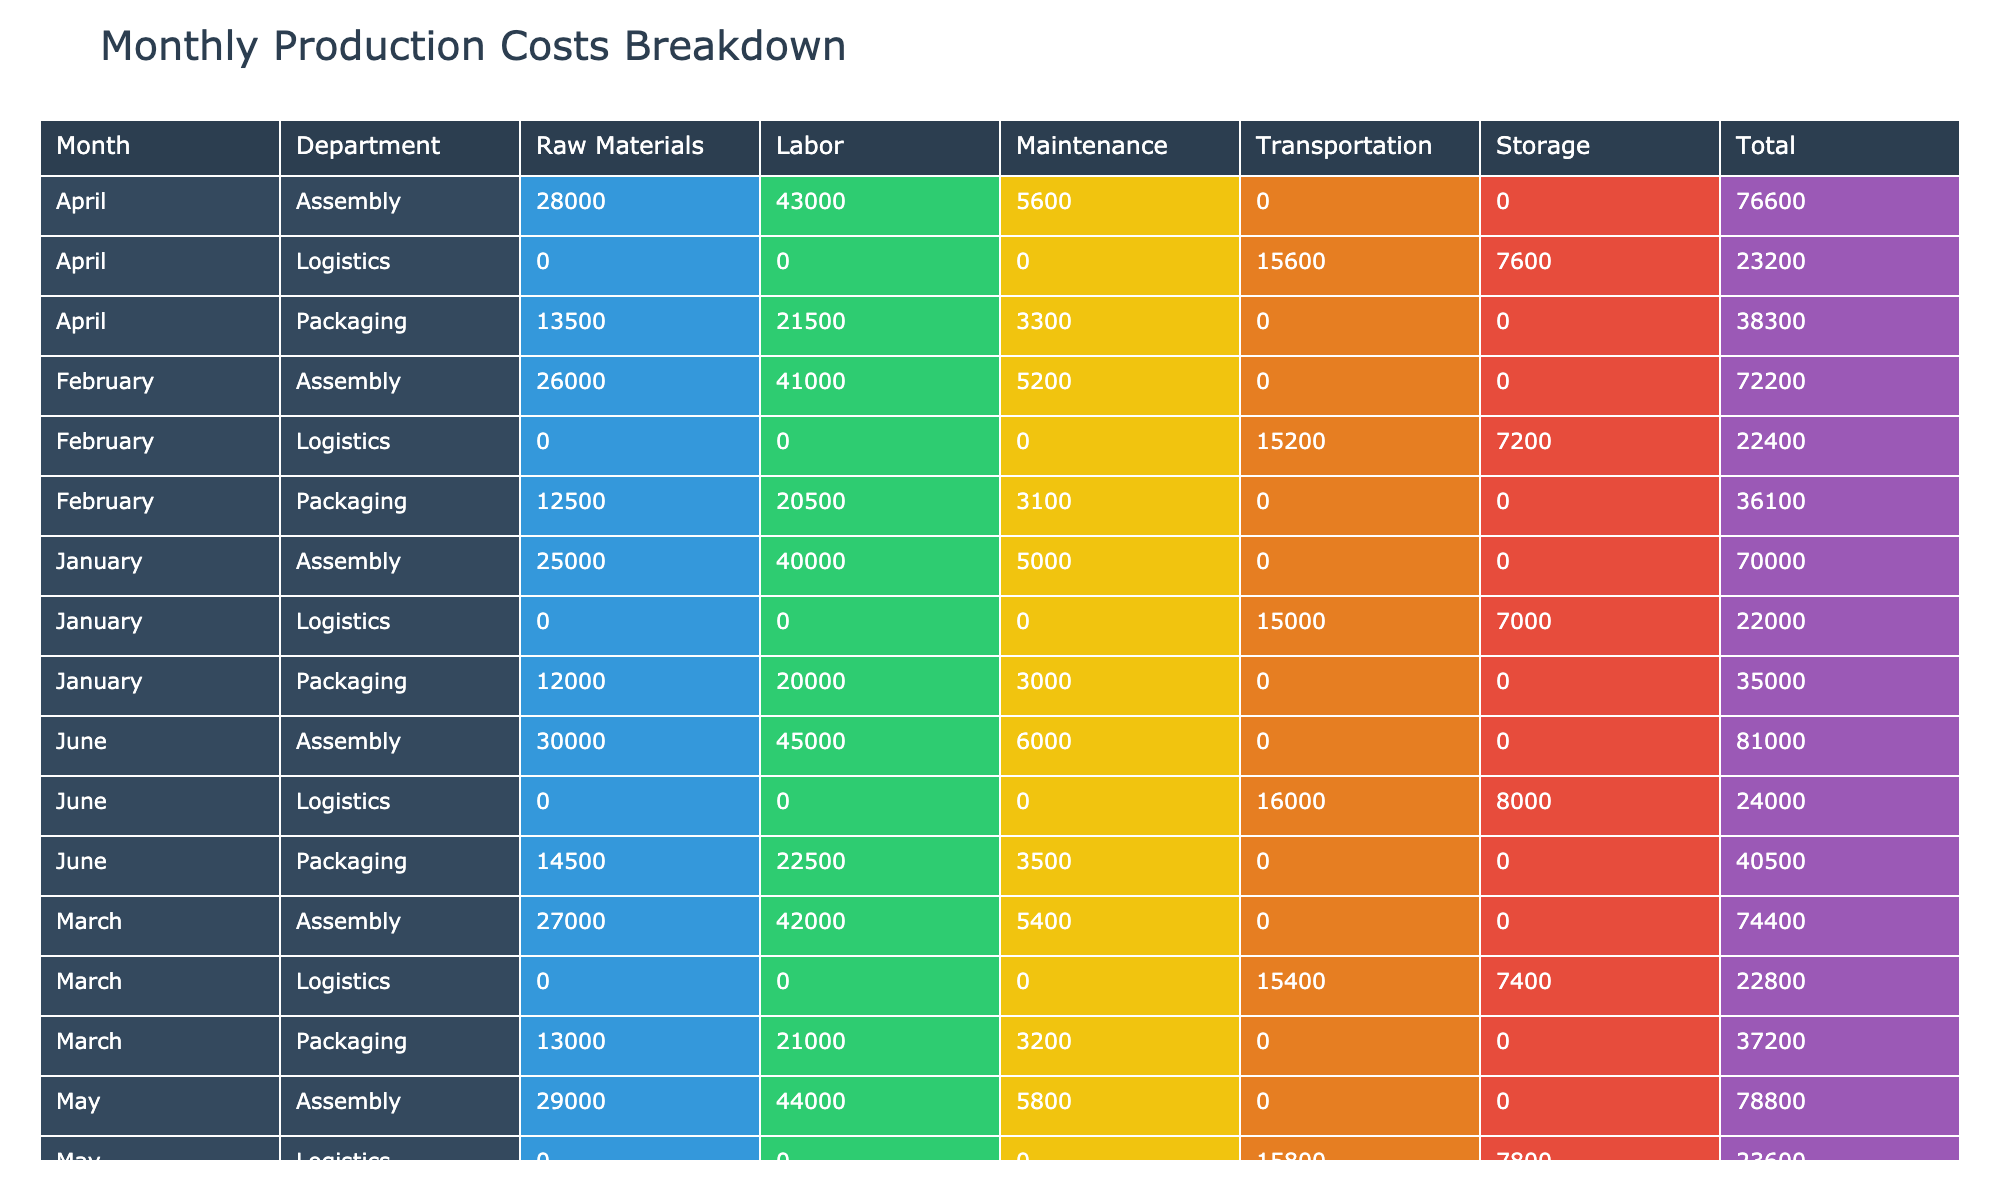What is the total cost for the Assembly department in April? The total cost for the Assembly department can be found in the row corresponding to April. The costs listed are: Raw Materials (28000), Labor (43000), and Maintenance (5600). Adding these values gives: 28000 + 43000 + 5600 = 76600.
Answer: 76600 Which month had the highest Logistics cost, and what was the total? To find the month with the highest Logistics cost, we look at all the total values in the Logistics rows across each month: January (22000), February (22400), March (22800), April (23200), May (23600), and June (24000). The highest value occurs in June at 24000.
Answer: June has the highest Logistics cost at 24000 What is the average cost of Raw Materials over the six months? To calculate the average cost of Raw Materials, we first sum the costs for each month: January (25000), February (26000), March (27000), April (28000), May (29000), and June (30000). The total equals 25000 + 26000 + 27000 + 28000 + 29000 + 30000 = 165000. Therefore, the average cost is 165000 divided by 6 months, which equals 27500.
Answer: 27500 Is the total Maintenance cost in February greater than that in January? In February, the Maintenance cost for all departments is: Assembly (5200), Packaging (3100), and Logistics (0). This totals to 8300. In January, the Maintenance costs were: Assembly (5000), Packaging (3000), and Logistics (0), totaling 8000. Since 8300 > 8000, February has a greater Maintenance cost than January.
Answer: Yes What percentage of the total costs in May came from Labor in the Packaging department? First, we calculate the total costs for May by summing all categories: Raw Materials (14000), Labor (22000), Maintenance (3400), Transportation (15800), and Storage (7800). This totals to 14000 + 22000 + 3400 + 15800 + 7800 = 57800. The Labor costs from the Packaging department in May was 22000. To find the percentage, we calculate (22000 / 57800) * 100, which equals approximately 38.1%.
Answer: 38.1% 